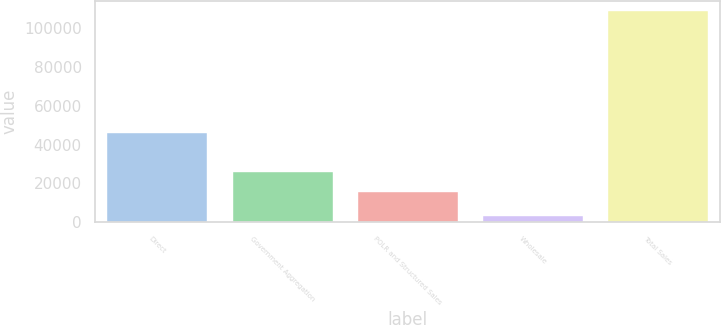<chart> <loc_0><loc_0><loc_500><loc_500><bar_chart><fcel>Direct<fcel>Government Aggregation<fcel>POLR and Structured Sales<fcel>Wholesale<fcel>Total Sales<nl><fcel>46187<fcel>25925.8<fcel>15340<fcel>2916<fcel>108774<nl></chart> 